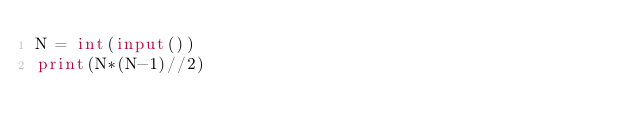Convert code to text. <code><loc_0><loc_0><loc_500><loc_500><_Python_>N = int(input())
print(N*(N-1)//2)
</code> 